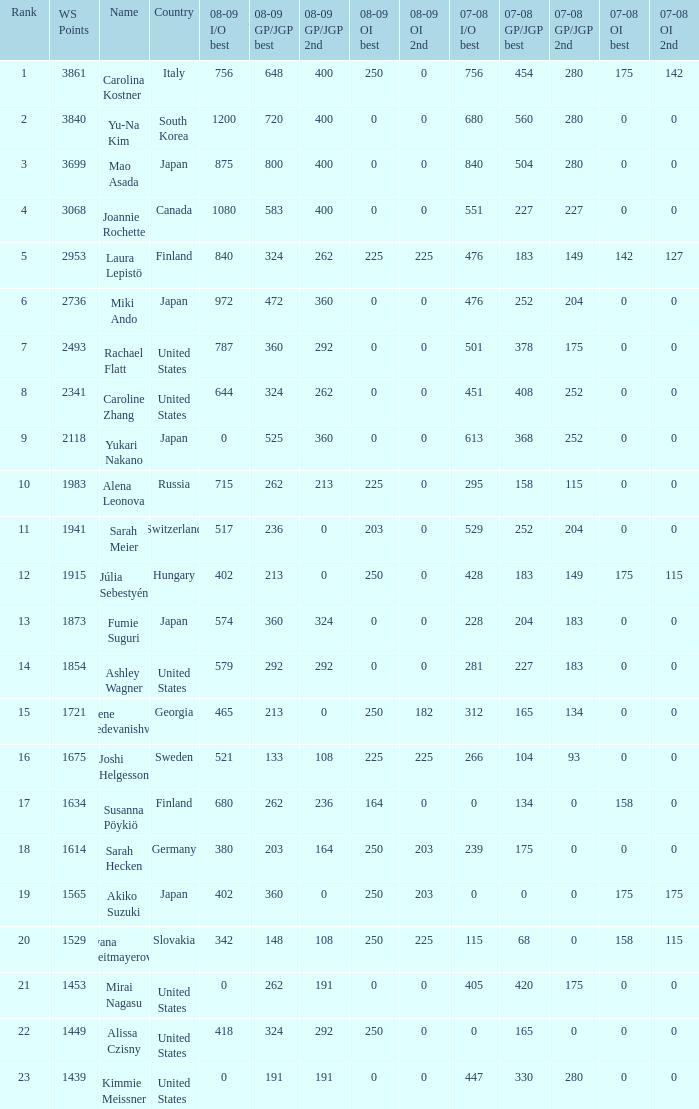Could you help me parse every detail presented in this table? {'header': ['Rank', 'WS Points', 'Name', 'Country', '08-09 I/O best', '08-09 GP/JGP best', '08-09 GP/JGP 2nd', '08-09 OI best', '08-09 OI 2nd', '07-08 I/O best', '07-08 GP/JGP best', '07-08 GP/JGP 2nd', '07-08 OI best', '07-08 OI 2nd'], 'rows': [['1', '3861', 'Carolina Kostner', 'Italy', '756', '648', '400', '250', '0', '756', '454', '280', '175', '142'], ['2', '3840', 'Yu-Na Kim', 'South Korea', '1200', '720', '400', '0', '0', '680', '560', '280', '0', '0'], ['3', '3699', 'Mao Asada', 'Japan', '875', '800', '400', '0', '0', '840', '504', '280', '0', '0'], ['4', '3068', 'Joannie Rochette', 'Canada', '1080', '583', '400', '0', '0', '551', '227', '227', '0', '0'], ['5', '2953', 'Laura Lepistö', 'Finland', '840', '324', '262', '225', '225', '476', '183', '149', '142', '127'], ['6', '2736', 'Miki Ando', 'Japan', '972', '472', '360', '0', '0', '476', '252', '204', '0', '0'], ['7', '2493', 'Rachael Flatt', 'United States', '787', '360', '292', '0', '0', '501', '378', '175', '0', '0'], ['8', '2341', 'Caroline Zhang', 'United States', '644', '324', '262', '0', '0', '451', '408', '252', '0', '0'], ['9', '2118', 'Yukari Nakano', 'Japan', '0', '525', '360', '0', '0', '613', '368', '252', '0', '0'], ['10', '1983', 'Alena Leonova', 'Russia', '715', '262', '213', '225', '0', '295', '158', '115', '0', '0'], ['11', '1941', 'Sarah Meier', 'Switzerland', '517', '236', '0', '203', '0', '529', '252', '204', '0', '0'], ['12', '1915', 'Júlia Sebestyén', 'Hungary', '402', '213', '0', '250', '0', '428', '183', '149', '175', '115'], ['13', '1873', 'Fumie Suguri', 'Japan', '574', '360', '324', '0', '0', '228', '204', '183', '0', '0'], ['14', '1854', 'Ashley Wagner', 'United States', '579', '292', '292', '0', '0', '281', '227', '183', '0', '0'], ['15', '1721', 'Elene Gedevanishvili', 'Georgia', '465', '213', '0', '250', '182', '312', '165', '134', '0', '0'], ['16', '1675', 'Joshi Helgesson', 'Sweden', '521', '133', '108', '225', '225', '266', '104', '93', '0', '0'], ['17', '1634', 'Susanna Pöykiö', 'Finland', '680', '262', '236', '164', '0', '0', '134', '0', '158', '0'], ['18', '1614', 'Sarah Hecken', 'Germany', '380', '203', '164', '250', '203', '239', '175', '0', '0', '0'], ['19', '1565', 'Akiko Suzuki', 'Japan', '402', '360', '0', '250', '203', '0', '0', '0', '175', '175'], ['20', '1529', 'Ivana Reitmayerova', 'Slovakia', '342', '148', '108', '250', '225', '115', '68', '0', '158', '115'], ['21', '1453', 'Mirai Nagasu', 'United States', '0', '262', '191', '0', '0', '405', '420', '175', '0', '0'], ['22', '1449', 'Alissa Czisny', 'United States', '418', '324', '292', '250', '0', '0', '165', '0', '0', '0'], ['23', '1439', 'Kimmie Meissner', 'United States', '0', '191', '191', '0', '0', '447', '330', '280', '0', '0']]} In 08-09 gp/jgp 2nd, if the score is 213 in ws, what is the highest possible points? 1983.0. 